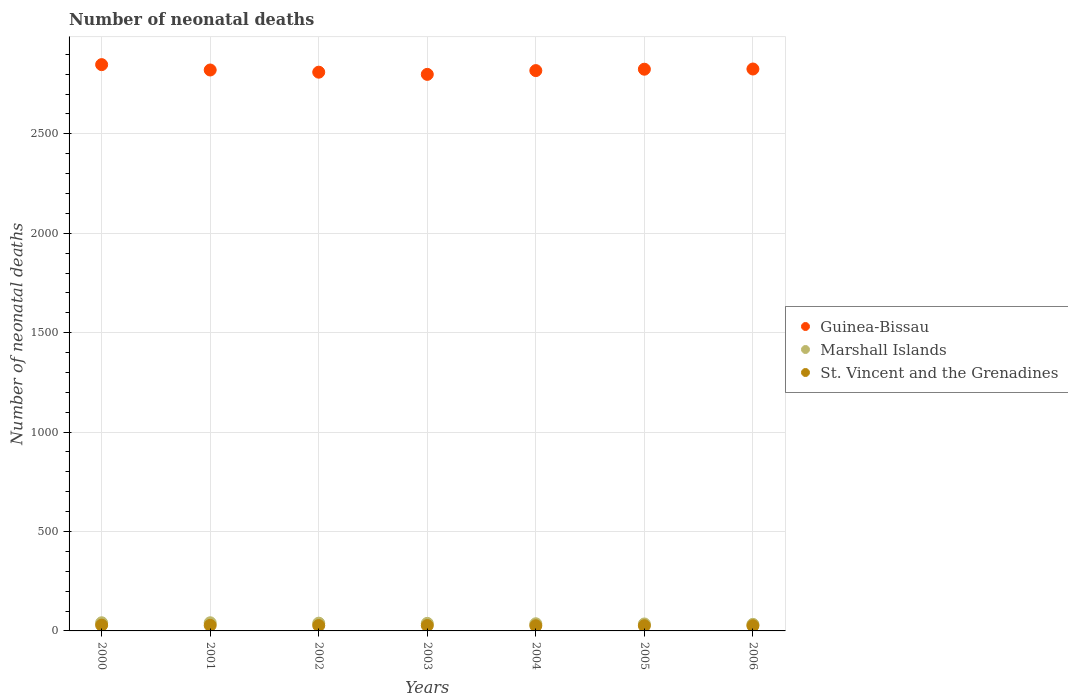Is the number of dotlines equal to the number of legend labels?
Offer a very short reply. Yes. What is the number of neonatal deaths in in Marshall Islands in 2000?
Give a very brief answer. 41. Across all years, what is the maximum number of neonatal deaths in in Guinea-Bissau?
Your answer should be very brief. 2848. Across all years, what is the minimum number of neonatal deaths in in St. Vincent and the Grenadines?
Make the answer very short. 26. In which year was the number of neonatal deaths in in St. Vincent and the Grenadines maximum?
Offer a very short reply. 2000. What is the total number of neonatal deaths in in St. Vincent and the Grenadines in the graph?
Your answer should be very brief. 189. What is the difference between the number of neonatal deaths in in St. Vincent and the Grenadines in 2004 and that in 2005?
Make the answer very short. 0. What is the difference between the number of neonatal deaths in in Guinea-Bissau in 2003 and the number of neonatal deaths in in Marshall Islands in 2000?
Provide a succinct answer. 2758. What is the average number of neonatal deaths in in Guinea-Bissau per year?
Your answer should be very brief. 2821. In the year 2001, what is the difference between the number of neonatal deaths in in Guinea-Bissau and number of neonatal deaths in in St. Vincent and the Grenadines?
Make the answer very short. 2793. What is the ratio of the number of neonatal deaths in in Marshall Islands in 2002 to that in 2006?
Give a very brief answer. 1.18. Is the number of neonatal deaths in in St. Vincent and the Grenadines in 2000 less than that in 2001?
Keep it short and to the point. No. Is the difference between the number of neonatal deaths in in Guinea-Bissau in 2000 and 2003 greater than the difference between the number of neonatal deaths in in St. Vincent and the Grenadines in 2000 and 2003?
Give a very brief answer. Yes. What is the difference between the highest and the second highest number of neonatal deaths in in Marshall Islands?
Offer a very short reply. 0. What is the difference between the highest and the lowest number of neonatal deaths in in Marshall Islands?
Ensure brevity in your answer.  8. Is it the case that in every year, the sum of the number of neonatal deaths in in Marshall Islands and number of neonatal deaths in in St. Vincent and the Grenadines  is greater than the number of neonatal deaths in in Guinea-Bissau?
Give a very brief answer. No. Does the number of neonatal deaths in in Marshall Islands monotonically increase over the years?
Keep it short and to the point. No. Is the number of neonatal deaths in in Guinea-Bissau strictly greater than the number of neonatal deaths in in Marshall Islands over the years?
Give a very brief answer. Yes. Are the values on the major ticks of Y-axis written in scientific E-notation?
Your answer should be compact. No. Does the graph contain grids?
Provide a short and direct response. Yes. What is the title of the graph?
Offer a very short reply. Number of neonatal deaths. Does "Germany" appear as one of the legend labels in the graph?
Offer a terse response. No. What is the label or title of the X-axis?
Your answer should be compact. Years. What is the label or title of the Y-axis?
Offer a terse response. Number of neonatal deaths. What is the Number of neonatal deaths of Guinea-Bissau in 2000?
Keep it short and to the point. 2848. What is the Number of neonatal deaths in St. Vincent and the Grenadines in 2000?
Make the answer very short. 29. What is the Number of neonatal deaths of Guinea-Bissau in 2001?
Offer a very short reply. 2821. What is the Number of neonatal deaths in Marshall Islands in 2001?
Your answer should be very brief. 41. What is the Number of neonatal deaths in Guinea-Bissau in 2002?
Provide a succinct answer. 2810. What is the Number of neonatal deaths in Guinea-Bissau in 2003?
Give a very brief answer. 2799. What is the Number of neonatal deaths in St. Vincent and the Grenadines in 2003?
Offer a very short reply. 27. What is the Number of neonatal deaths of Guinea-Bissau in 2004?
Your answer should be very brief. 2818. What is the Number of neonatal deaths of Guinea-Bissau in 2005?
Keep it short and to the point. 2825. What is the Number of neonatal deaths in St. Vincent and the Grenadines in 2005?
Make the answer very short. 26. What is the Number of neonatal deaths in Guinea-Bissau in 2006?
Your response must be concise. 2826. What is the Number of neonatal deaths of Marshall Islands in 2006?
Your answer should be compact. 33. Across all years, what is the maximum Number of neonatal deaths in Guinea-Bissau?
Ensure brevity in your answer.  2848. Across all years, what is the minimum Number of neonatal deaths of Guinea-Bissau?
Offer a terse response. 2799. What is the total Number of neonatal deaths in Guinea-Bissau in the graph?
Make the answer very short. 1.97e+04. What is the total Number of neonatal deaths of Marshall Islands in the graph?
Your answer should be very brief. 263. What is the total Number of neonatal deaths in St. Vincent and the Grenadines in the graph?
Give a very brief answer. 189. What is the difference between the Number of neonatal deaths of Guinea-Bissau in 2000 and that in 2001?
Ensure brevity in your answer.  27. What is the difference between the Number of neonatal deaths of Marshall Islands in 2000 and that in 2002?
Keep it short and to the point. 2. What is the difference between the Number of neonatal deaths of St. Vincent and the Grenadines in 2000 and that in 2002?
Your answer should be very brief. 2. What is the difference between the Number of neonatal deaths in Guinea-Bissau in 2000 and that in 2003?
Provide a short and direct response. 49. What is the difference between the Number of neonatal deaths in Marshall Islands in 2000 and that in 2003?
Keep it short and to the point. 3. What is the difference between the Number of neonatal deaths in St. Vincent and the Grenadines in 2000 and that in 2003?
Give a very brief answer. 2. What is the difference between the Number of neonatal deaths in Guinea-Bissau in 2000 and that in 2004?
Ensure brevity in your answer.  30. What is the difference between the Number of neonatal deaths in St. Vincent and the Grenadines in 2000 and that in 2005?
Keep it short and to the point. 3. What is the difference between the Number of neonatal deaths in St. Vincent and the Grenadines in 2000 and that in 2006?
Keep it short and to the point. 3. What is the difference between the Number of neonatal deaths in Guinea-Bissau in 2001 and that in 2002?
Provide a short and direct response. 11. What is the difference between the Number of neonatal deaths of Marshall Islands in 2001 and that in 2002?
Ensure brevity in your answer.  2. What is the difference between the Number of neonatal deaths in Guinea-Bissau in 2001 and that in 2003?
Ensure brevity in your answer.  22. What is the difference between the Number of neonatal deaths of Marshall Islands in 2001 and that in 2003?
Make the answer very short. 3. What is the difference between the Number of neonatal deaths in Marshall Islands in 2001 and that in 2004?
Offer a very short reply. 5. What is the difference between the Number of neonatal deaths of St. Vincent and the Grenadines in 2001 and that in 2004?
Offer a terse response. 2. What is the difference between the Number of neonatal deaths of Guinea-Bissau in 2001 and that in 2005?
Your answer should be very brief. -4. What is the difference between the Number of neonatal deaths of Marshall Islands in 2001 and that in 2005?
Keep it short and to the point. 6. What is the difference between the Number of neonatal deaths of Guinea-Bissau in 2001 and that in 2006?
Your response must be concise. -5. What is the difference between the Number of neonatal deaths of St. Vincent and the Grenadines in 2002 and that in 2003?
Ensure brevity in your answer.  0. What is the difference between the Number of neonatal deaths of Marshall Islands in 2002 and that in 2004?
Provide a short and direct response. 3. What is the difference between the Number of neonatal deaths of St. Vincent and the Grenadines in 2002 and that in 2004?
Offer a very short reply. 1. What is the difference between the Number of neonatal deaths in Guinea-Bissau in 2002 and that in 2005?
Your response must be concise. -15. What is the difference between the Number of neonatal deaths of St. Vincent and the Grenadines in 2002 and that in 2005?
Give a very brief answer. 1. What is the difference between the Number of neonatal deaths of St. Vincent and the Grenadines in 2002 and that in 2006?
Offer a terse response. 1. What is the difference between the Number of neonatal deaths of Marshall Islands in 2003 and that in 2004?
Ensure brevity in your answer.  2. What is the difference between the Number of neonatal deaths in St. Vincent and the Grenadines in 2003 and that in 2005?
Offer a very short reply. 1. What is the difference between the Number of neonatal deaths of Guinea-Bissau in 2003 and that in 2006?
Provide a succinct answer. -27. What is the difference between the Number of neonatal deaths of Guinea-Bissau in 2004 and that in 2005?
Your answer should be very brief. -7. What is the difference between the Number of neonatal deaths of Marshall Islands in 2004 and that in 2006?
Give a very brief answer. 3. What is the difference between the Number of neonatal deaths of Guinea-Bissau in 2005 and that in 2006?
Provide a succinct answer. -1. What is the difference between the Number of neonatal deaths in Marshall Islands in 2005 and that in 2006?
Your answer should be very brief. 2. What is the difference between the Number of neonatal deaths in Guinea-Bissau in 2000 and the Number of neonatal deaths in Marshall Islands in 2001?
Provide a succinct answer. 2807. What is the difference between the Number of neonatal deaths of Guinea-Bissau in 2000 and the Number of neonatal deaths of St. Vincent and the Grenadines in 2001?
Give a very brief answer. 2820. What is the difference between the Number of neonatal deaths of Guinea-Bissau in 2000 and the Number of neonatal deaths of Marshall Islands in 2002?
Ensure brevity in your answer.  2809. What is the difference between the Number of neonatal deaths of Guinea-Bissau in 2000 and the Number of neonatal deaths of St. Vincent and the Grenadines in 2002?
Ensure brevity in your answer.  2821. What is the difference between the Number of neonatal deaths of Marshall Islands in 2000 and the Number of neonatal deaths of St. Vincent and the Grenadines in 2002?
Your answer should be compact. 14. What is the difference between the Number of neonatal deaths in Guinea-Bissau in 2000 and the Number of neonatal deaths in Marshall Islands in 2003?
Offer a terse response. 2810. What is the difference between the Number of neonatal deaths in Guinea-Bissau in 2000 and the Number of neonatal deaths in St. Vincent and the Grenadines in 2003?
Ensure brevity in your answer.  2821. What is the difference between the Number of neonatal deaths of Marshall Islands in 2000 and the Number of neonatal deaths of St. Vincent and the Grenadines in 2003?
Your answer should be compact. 14. What is the difference between the Number of neonatal deaths in Guinea-Bissau in 2000 and the Number of neonatal deaths in Marshall Islands in 2004?
Make the answer very short. 2812. What is the difference between the Number of neonatal deaths in Guinea-Bissau in 2000 and the Number of neonatal deaths in St. Vincent and the Grenadines in 2004?
Ensure brevity in your answer.  2822. What is the difference between the Number of neonatal deaths of Guinea-Bissau in 2000 and the Number of neonatal deaths of Marshall Islands in 2005?
Your answer should be compact. 2813. What is the difference between the Number of neonatal deaths of Guinea-Bissau in 2000 and the Number of neonatal deaths of St. Vincent and the Grenadines in 2005?
Offer a terse response. 2822. What is the difference between the Number of neonatal deaths of Marshall Islands in 2000 and the Number of neonatal deaths of St. Vincent and the Grenadines in 2005?
Ensure brevity in your answer.  15. What is the difference between the Number of neonatal deaths of Guinea-Bissau in 2000 and the Number of neonatal deaths of Marshall Islands in 2006?
Offer a very short reply. 2815. What is the difference between the Number of neonatal deaths of Guinea-Bissau in 2000 and the Number of neonatal deaths of St. Vincent and the Grenadines in 2006?
Give a very brief answer. 2822. What is the difference between the Number of neonatal deaths of Guinea-Bissau in 2001 and the Number of neonatal deaths of Marshall Islands in 2002?
Provide a short and direct response. 2782. What is the difference between the Number of neonatal deaths in Guinea-Bissau in 2001 and the Number of neonatal deaths in St. Vincent and the Grenadines in 2002?
Your answer should be very brief. 2794. What is the difference between the Number of neonatal deaths of Guinea-Bissau in 2001 and the Number of neonatal deaths of Marshall Islands in 2003?
Offer a terse response. 2783. What is the difference between the Number of neonatal deaths of Guinea-Bissau in 2001 and the Number of neonatal deaths of St. Vincent and the Grenadines in 2003?
Make the answer very short. 2794. What is the difference between the Number of neonatal deaths of Guinea-Bissau in 2001 and the Number of neonatal deaths of Marshall Islands in 2004?
Provide a short and direct response. 2785. What is the difference between the Number of neonatal deaths in Guinea-Bissau in 2001 and the Number of neonatal deaths in St. Vincent and the Grenadines in 2004?
Your answer should be very brief. 2795. What is the difference between the Number of neonatal deaths in Guinea-Bissau in 2001 and the Number of neonatal deaths in Marshall Islands in 2005?
Ensure brevity in your answer.  2786. What is the difference between the Number of neonatal deaths in Guinea-Bissau in 2001 and the Number of neonatal deaths in St. Vincent and the Grenadines in 2005?
Give a very brief answer. 2795. What is the difference between the Number of neonatal deaths in Marshall Islands in 2001 and the Number of neonatal deaths in St. Vincent and the Grenadines in 2005?
Offer a very short reply. 15. What is the difference between the Number of neonatal deaths of Guinea-Bissau in 2001 and the Number of neonatal deaths of Marshall Islands in 2006?
Keep it short and to the point. 2788. What is the difference between the Number of neonatal deaths of Guinea-Bissau in 2001 and the Number of neonatal deaths of St. Vincent and the Grenadines in 2006?
Make the answer very short. 2795. What is the difference between the Number of neonatal deaths of Marshall Islands in 2001 and the Number of neonatal deaths of St. Vincent and the Grenadines in 2006?
Ensure brevity in your answer.  15. What is the difference between the Number of neonatal deaths in Guinea-Bissau in 2002 and the Number of neonatal deaths in Marshall Islands in 2003?
Your answer should be very brief. 2772. What is the difference between the Number of neonatal deaths in Guinea-Bissau in 2002 and the Number of neonatal deaths in St. Vincent and the Grenadines in 2003?
Provide a short and direct response. 2783. What is the difference between the Number of neonatal deaths in Guinea-Bissau in 2002 and the Number of neonatal deaths in Marshall Islands in 2004?
Keep it short and to the point. 2774. What is the difference between the Number of neonatal deaths of Guinea-Bissau in 2002 and the Number of neonatal deaths of St. Vincent and the Grenadines in 2004?
Your answer should be very brief. 2784. What is the difference between the Number of neonatal deaths in Marshall Islands in 2002 and the Number of neonatal deaths in St. Vincent and the Grenadines in 2004?
Your answer should be compact. 13. What is the difference between the Number of neonatal deaths of Guinea-Bissau in 2002 and the Number of neonatal deaths of Marshall Islands in 2005?
Your answer should be compact. 2775. What is the difference between the Number of neonatal deaths in Guinea-Bissau in 2002 and the Number of neonatal deaths in St. Vincent and the Grenadines in 2005?
Give a very brief answer. 2784. What is the difference between the Number of neonatal deaths of Marshall Islands in 2002 and the Number of neonatal deaths of St. Vincent and the Grenadines in 2005?
Your response must be concise. 13. What is the difference between the Number of neonatal deaths of Guinea-Bissau in 2002 and the Number of neonatal deaths of Marshall Islands in 2006?
Make the answer very short. 2777. What is the difference between the Number of neonatal deaths of Guinea-Bissau in 2002 and the Number of neonatal deaths of St. Vincent and the Grenadines in 2006?
Your answer should be very brief. 2784. What is the difference between the Number of neonatal deaths of Guinea-Bissau in 2003 and the Number of neonatal deaths of Marshall Islands in 2004?
Your answer should be compact. 2763. What is the difference between the Number of neonatal deaths of Guinea-Bissau in 2003 and the Number of neonatal deaths of St. Vincent and the Grenadines in 2004?
Provide a short and direct response. 2773. What is the difference between the Number of neonatal deaths of Guinea-Bissau in 2003 and the Number of neonatal deaths of Marshall Islands in 2005?
Provide a short and direct response. 2764. What is the difference between the Number of neonatal deaths of Guinea-Bissau in 2003 and the Number of neonatal deaths of St. Vincent and the Grenadines in 2005?
Make the answer very short. 2773. What is the difference between the Number of neonatal deaths of Guinea-Bissau in 2003 and the Number of neonatal deaths of Marshall Islands in 2006?
Offer a terse response. 2766. What is the difference between the Number of neonatal deaths in Guinea-Bissau in 2003 and the Number of neonatal deaths in St. Vincent and the Grenadines in 2006?
Keep it short and to the point. 2773. What is the difference between the Number of neonatal deaths in Guinea-Bissau in 2004 and the Number of neonatal deaths in Marshall Islands in 2005?
Provide a succinct answer. 2783. What is the difference between the Number of neonatal deaths of Guinea-Bissau in 2004 and the Number of neonatal deaths of St. Vincent and the Grenadines in 2005?
Your response must be concise. 2792. What is the difference between the Number of neonatal deaths of Marshall Islands in 2004 and the Number of neonatal deaths of St. Vincent and the Grenadines in 2005?
Offer a very short reply. 10. What is the difference between the Number of neonatal deaths in Guinea-Bissau in 2004 and the Number of neonatal deaths in Marshall Islands in 2006?
Provide a succinct answer. 2785. What is the difference between the Number of neonatal deaths in Guinea-Bissau in 2004 and the Number of neonatal deaths in St. Vincent and the Grenadines in 2006?
Provide a succinct answer. 2792. What is the difference between the Number of neonatal deaths in Marshall Islands in 2004 and the Number of neonatal deaths in St. Vincent and the Grenadines in 2006?
Offer a terse response. 10. What is the difference between the Number of neonatal deaths in Guinea-Bissau in 2005 and the Number of neonatal deaths in Marshall Islands in 2006?
Your response must be concise. 2792. What is the difference between the Number of neonatal deaths of Guinea-Bissau in 2005 and the Number of neonatal deaths of St. Vincent and the Grenadines in 2006?
Offer a terse response. 2799. What is the average Number of neonatal deaths of Guinea-Bissau per year?
Offer a terse response. 2821. What is the average Number of neonatal deaths in Marshall Islands per year?
Provide a succinct answer. 37.57. What is the average Number of neonatal deaths in St. Vincent and the Grenadines per year?
Your answer should be very brief. 27. In the year 2000, what is the difference between the Number of neonatal deaths of Guinea-Bissau and Number of neonatal deaths of Marshall Islands?
Provide a succinct answer. 2807. In the year 2000, what is the difference between the Number of neonatal deaths of Guinea-Bissau and Number of neonatal deaths of St. Vincent and the Grenadines?
Ensure brevity in your answer.  2819. In the year 2000, what is the difference between the Number of neonatal deaths in Marshall Islands and Number of neonatal deaths in St. Vincent and the Grenadines?
Make the answer very short. 12. In the year 2001, what is the difference between the Number of neonatal deaths in Guinea-Bissau and Number of neonatal deaths in Marshall Islands?
Keep it short and to the point. 2780. In the year 2001, what is the difference between the Number of neonatal deaths in Guinea-Bissau and Number of neonatal deaths in St. Vincent and the Grenadines?
Ensure brevity in your answer.  2793. In the year 2002, what is the difference between the Number of neonatal deaths of Guinea-Bissau and Number of neonatal deaths of Marshall Islands?
Your answer should be compact. 2771. In the year 2002, what is the difference between the Number of neonatal deaths of Guinea-Bissau and Number of neonatal deaths of St. Vincent and the Grenadines?
Give a very brief answer. 2783. In the year 2002, what is the difference between the Number of neonatal deaths of Marshall Islands and Number of neonatal deaths of St. Vincent and the Grenadines?
Keep it short and to the point. 12. In the year 2003, what is the difference between the Number of neonatal deaths in Guinea-Bissau and Number of neonatal deaths in Marshall Islands?
Give a very brief answer. 2761. In the year 2003, what is the difference between the Number of neonatal deaths in Guinea-Bissau and Number of neonatal deaths in St. Vincent and the Grenadines?
Offer a very short reply. 2772. In the year 2003, what is the difference between the Number of neonatal deaths of Marshall Islands and Number of neonatal deaths of St. Vincent and the Grenadines?
Offer a very short reply. 11. In the year 2004, what is the difference between the Number of neonatal deaths of Guinea-Bissau and Number of neonatal deaths of Marshall Islands?
Offer a terse response. 2782. In the year 2004, what is the difference between the Number of neonatal deaths of Guinea-Bissau and Number of neonatal deaths of St. Vincent and the Grenadines?
Your answer should be compact. 2792. In the year 2005, what is the difference between the Number of neonatal deaths in Guinea-Bissau and Number of neonatal deaths in Marshall Islands?
Keep it short and to the point. 2790. In the year 2005, what is the difference between the Number of neonatal deaths in Guinea-Bissau and Number of neonatal deaths in St. Vincent and the Grenadines?
Your answer should be compact. 2799. In the year 2006, what is the difference between the Number of neonatal deaths in Guinea-Bissau and Number of neonatal deaths in Marshall Islands?
Your response must be concise. 2793. In the year 2006, what is the difference between the Number of neonatal deaths of Guinea-Bissau and Number of neonatal deaths of St. Vincent and the Grenadines?
Give a very brief answer. 2800. In the year 2006, what is the difference between the Number of neonatal deaths in Marshall Islands and Number of neonatal deaths in St. Vincent and the Grenadines?
Provide a short and direct response. 7. What is the ratio of the Number of neonatal deaths of Guinea-Bissau in 2000 to that in 2001?
Keep it short and to the point. 1.01. What is the ratio of the Number of neonatal deaths in St. Vincent and the Grenadines in 2000 to that in 2001?
Keep it short and to the point. 1.04. What is the ratio of the Number of neonatal deaths of Guinea-Bissau in 2000 to that in 2002?
Offer a terse response. 1.01. What is the ratio of the Number of neonatal deaths of Marshall Islands in 2000 to that in 2002?
Provide a short and direct response. 1.05. What is the ratio of the Number of neonatal deaths in St. Vincent and the Grenadines in 2000 to that in 2002?
Give a very brief answer. 1.07. What is the ratio of the Number of neonatal deaths in Guinea-Bissau in 2000 to that in 2003?
Ensure brevity in your answer.  1.02. What is the ratio of the Number of neonatal deaths of Marshall Islands in 2000 to that in 2003?
Offer a very short reply. 1.08. What is the ratio of the Number of neonatal deaths in St. Vincent and the Grenadines in 2000 to that in 2003?
Your answer should be very brief. 1.07. What is the ratio of the Number of neonatal deaths of Guinea-Bissau in 2000 to that in 2004?
Keep it short and to the point. 1.01. What is the ratio of the Number of neonatal deaths of Marshall Islands in 2000 to that in 2004?
Offer a terse response. 1.14. What is the ratio of the Number of neonatal deaths in St. Vincent and the Grenadines in 2000 to that in 2004?
Make the answer very short. 1.12. What is the ratio of the Number of neonatal deaths in Guinea-Bissau in 2000 to that in 2005?
Your answer should be very brief. 1.01. What is the ratio of the Number of neonatal deaths in Marshall Islands in 2000 to that in 2005?
Keep it short and to the point. 1.17. What is the ratio of the Number of neonatal deaths of St. Vincent and the Grenadines in 2000 to that in 2005?
Offer a terse response. 1.12. What is the ratio of the Number of neonatal deaths of Guinea-Bissau in 2000 to that in 2006?
Provide a succinct answer. 1.01. What is the ratio of the Number of neonatal deaths in Marshall Islands in 2000 to that in 2006?
Your response must be concise. 1.24. What is the ratio of the Number of neonatal deaths in St. Vincent and the Grenadines in 2000 to that in 2006?
Offer a terse response. 1.12. What is the ratio of the Number of neonatal deaths of Guinea-Bissau in 2001 to that in 2002?
Provide a succinct answer. 1. What is the ratio of the Number of neonatal deaths in Marshall Islands in 2001 to that in 2002?
Your answer should be very brief. 1.05. What is the ratio of the Number of neonatal deaths in St. Vincent and the Grenadines in 2001 to that in 2002?
Your response must be concise. 1.04. What is the ratio of the Number of neonatal deaths in Guinea-Bissau in 2001 to that in 2003?
Provide a succinct answer. 1.01. What is the ratio of the Number of neonatal deaths of Marshall Islands in 2001 to that in 2003?
Your answer should be very brief. 1.08. What is the ratio of the Number of neonatal deaths of Marshall Islands in 2001 to that in 2004?
Offer a very short reply. 1.14. What is the ratio of the Number of neonatal deaths in Guinea-Bissau in 2001 to that in 2005?
Your answer should be compact. 1. What is the ratio of the Number of neonatal deaths of Marshall Islands in 2001 to that in 2005?
Your response must be concise. 1.17. What is the ratio of the Number of neonatal deaths in Guinea-Bissau in 2001 to that in 2006?
Keep it short and to the point. 1. What is the ratio of the Number of neonatal deaths in Marshall Islands in 2001 to that in 2006?
Offer a very short reply. 1.24. What is the ratio of the Number of neonatal deaths of Marshall Islands in 2002 to that in 2003?
Make the answer very short. 1.03. What is the ratio of the Number of neonatal deaths in St. Vincent and the Grenadines in 2002 to that in 2003?
Provide a succinct answer. 1. What is the ratio of the Number of neonatal deaths in Guinea-Bissau in 2002 to that in 2004?
Provide a succinct answer. 1. What is the ratio of the Number of neonatal deaths of St. Vincent and the Grenadines in 2002 to that in 2004?
Your answer should be very brief. 1.04. What is the ratio of the Number of neonatal deaths in Guinea-Bissau in 2002 to that in 2005?
Give a very brief answer. 0.99. What is the ratio of the Number of neonatal deaths of Marshall Islands in 2002 to that in 2005?
Your answer should be compact. 1.11. What is the ratio of the Number of neonatal deaths in Marshall Islands in 2002 to that in 2006?
Give a very brief answer. 1.18. What is the ratio of the Number of neonatal deaths in St. Vincent and the Grenadines in 2002 to that in 2006?
Your answer should be very brief. 1.04. What is the ratio of the Number of neonatal deaths in Guinea-Bissau in 2003 to that in 2004?
Keep it short and to the point. 0.99. What is the ratio of the Number of neonatal deaths of Marshall Islands in 2003 to that in 2004?
Offer a very short reply. 1.06. What is the ratio of the Number of neonatal deaths in St. Vincent and the Grenadines in 2003 to that in 2004?
Give a very brief answer. 1.04. What is the ratio of the Number of neonatal deaths of Guinea-Bissau in 2003 to that in 2005?
Offer a terse response. 0.99. What is the ratio of the Number of neonatal deaths in Marshall Islands in 2003 to that in 2005?
Provide a succinct answer. 1.09. What is the ratio of the Number of neonatal deaths of Guinea-Bissau in 2003 to that in 2006?
Offer a terse response. 0.99. What is the ratio of the Number of neonatal deaths in Marshall Islands in 2003 to that in 2006?
Offer a very short reply. 1.15. What is the ratio of the Number of neonatal deaths of Marshall Islands in 2004 to that in 2005?
Make the answer very short. 1.03. What is the ratio of the Number of neonatal deaths of St. Vincent and the Grenadines in 2004 to that in 2005?
Provide a short and direct response. 1. What is the ratio of the Number of neonatal deaths in Marshall Islands in 2004 to that in 2006?
Your answer should be compact. 1.09. What is the ratio of the Number of neonatal deaths of Guinea-Bissau in 2005 to that in 2006?
Your answer should be compact. 1. What is the ratio of the Number of neonatal deaths in Marshall Islands in 2005 to that in 2006?
Offer a terse response. 1.06. What is the difference between the highest and the second highest Number of neonatal deaths in Guinea-Bissau?
Provide a succinct answer. 22. What is the difference between the highest and the lowest Number of neonatal deaths in Guinea-Bissau?
Ensure brevity in your answer.  49. 